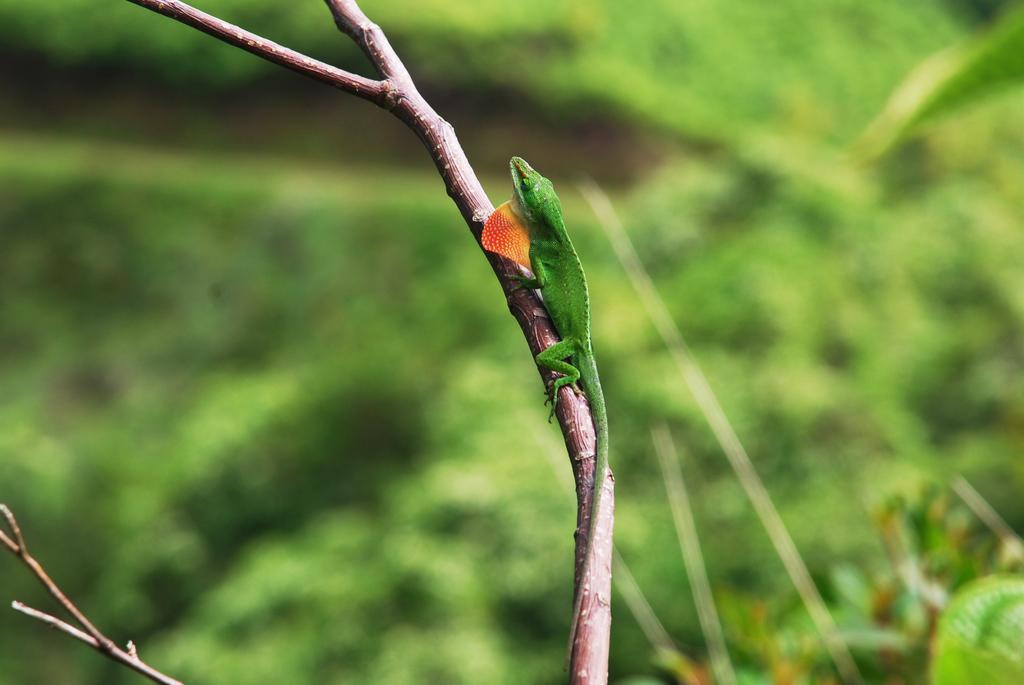Can you describe this image briefly? In this image I can see a green color reptile on the stem and background is in green color. 